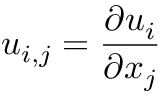<formula> <loc_0><loc_0><loc_500><loc_500>u _ { i , j } = \frac { \partial u _ { i } } { \partial x _ { j } }</formula> 